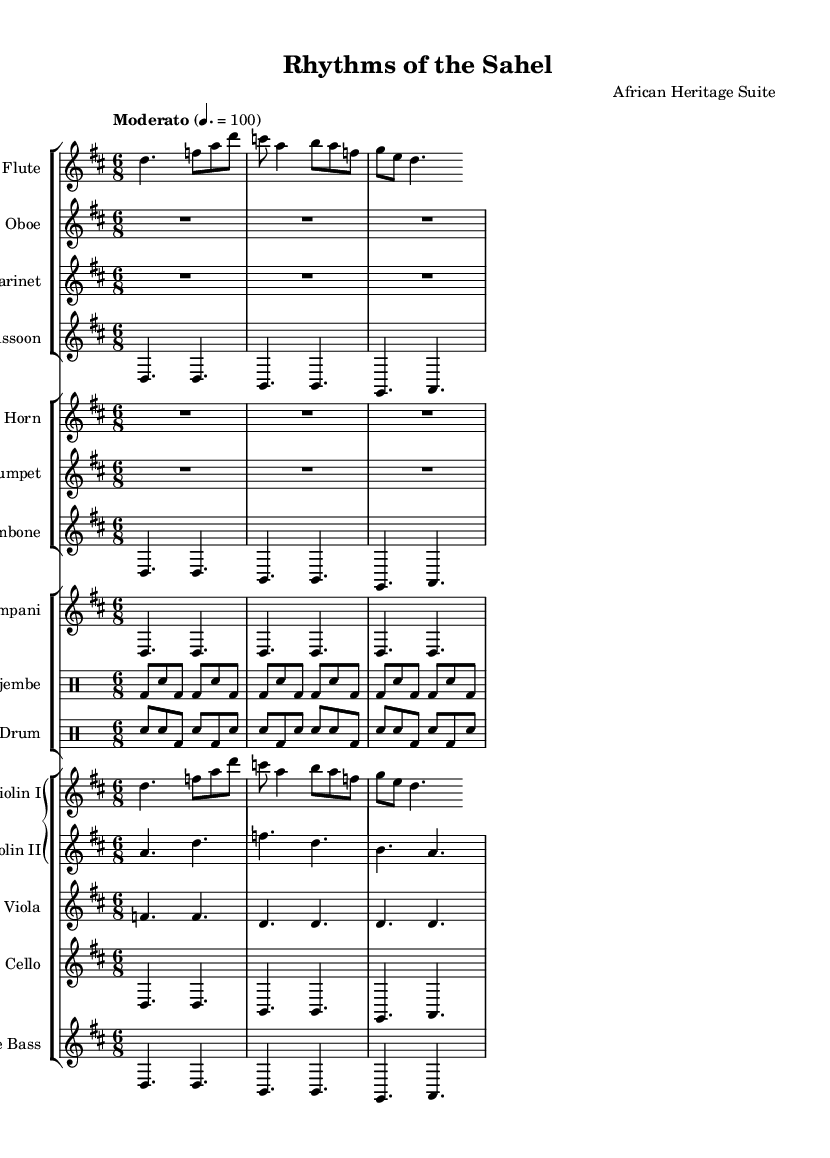What is the key signature of this music? The key signature is indicated at the beginning of the piece. In the provided score, it shows two sharps, which represent the notes F sharp and C sharp. This is characteristic of D major.
Answer: D major What is the time signature of this music? The time signature appears after the key signature at the beginning of the score. Here, it is marked as 6/8, which indicates that there are six eighth notes in each measure.
Answer: 6/8 What is the tempo marking for this piece? The tempo marking is provided in the score above the staff entries. It indicates that the piece should be played "Moderato," which translates to a moderate speed, in this case, marked at quarter note = 100.
Answer: Moderato Which instruments are featured in the percussion section? The percussion section consists of the Djembe and the Talking Drum, both of which are indicated in separate drum staffs in the score.
Answer: Djembe, Talking Drum How many measures are allocated to the flute part in the playing sections shown? By counting the measures in the flute staff, we see that it contains three measures before it replicates. Each measure is separated by a vertical bar line.
Answer: Three measures Compare the parts of violin I and violin II: are they identical? Observing both parts shows that while they begin similarly, violin I does not repeat the exact sequence as violin II does, indicating they have different melodic lines.
Answer: No What is the first note played by the double bass? The first note is identifiable from the double bass staff, where the note is shown to be D in the initial measure.
Answer: D 